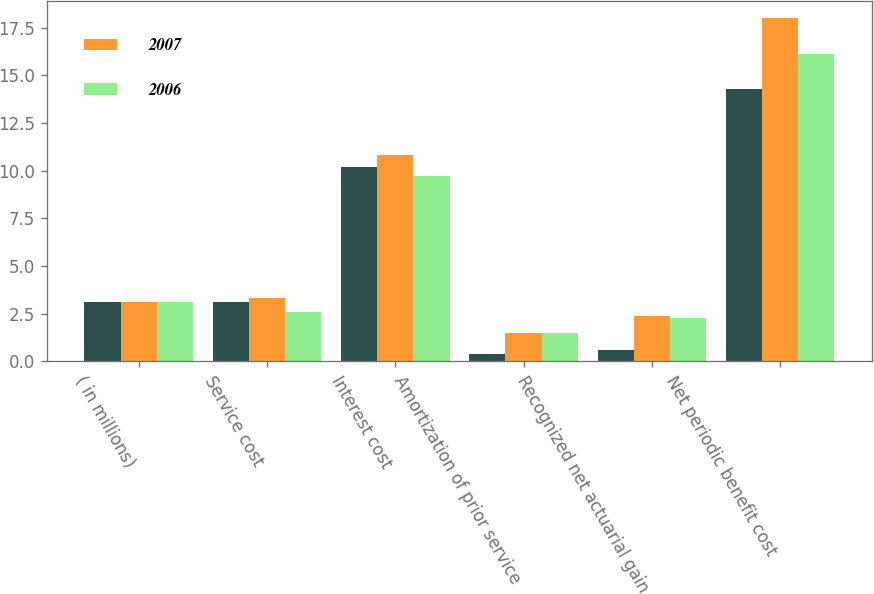<chart> <loc_0><loc_0><loc_500><loc_500><stacked_bar_chart><ecel><fcel>( in millions)<fcel>Service cost<fcel>Interest cost<fcel>Amortization of prior service<fcel>Recognized net actuarial gain<fcel>Net periodic benefit cost<nl><fcel>nan<fcel>3.1<fcel>3.1<fcel>10.2<fcel>0.4<fcel>0.6<fcel>14.3<nl><fcel>2007<fcel>3.1<fcel>3.3<fcel>10.8<fcel>1.5<fcel>2.4<fcel>18<nl><fcel>2006<fcel>3.1<fcel>2.6<fcel>9.7<fcel>1.5<fcel>2.3<fcel>16.1<nl></chart> 